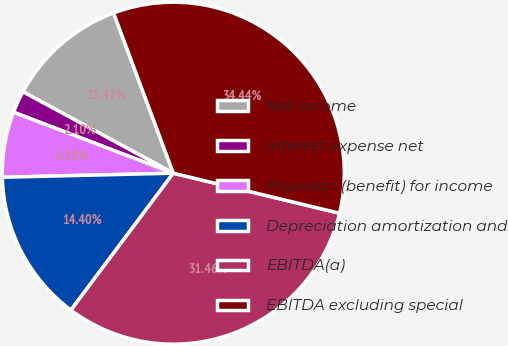<chart> <loc_0><loc_0><loc_500><loc_500><pie_chart><fcel>Net income<fcel>Interest expense net<fcel>Provision (benefit) for income<fcel>Depreciation amortization and<fcel>EBITDA(a)<fcel>EBITDA excluding special<nl><fcel>11.42%<fcel>2.1%<fcel>6.18%<fcel>14.4%<fcel>31.46%<fcel>34.44%<nl></chart> 